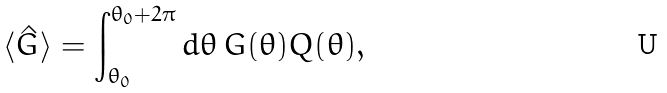Convert formula to latex. <formula><loc_0><loc_0><loc_500><loc_500>\langle \hat { G } \rangle = \int _ { \theta _ { 0 } } ^ { \theta _ { 0 } + 2 \pi } d \theta \, G ( \theta ) Q ( \theta ) ,</formula> 